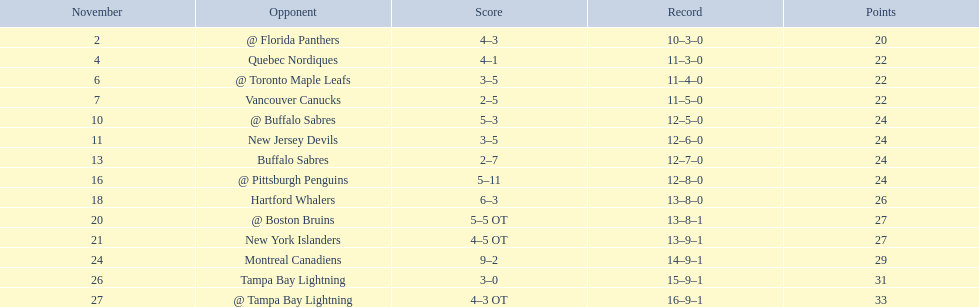Who did the philadelphia flyers play in game 17? @ Buffalo Sabres. What was the score of the november 10th game against the buffalo sabres? 5–3. Which team in the atlantic division had less points than the philadelphia flyers? Tampa Bay Lightning. 